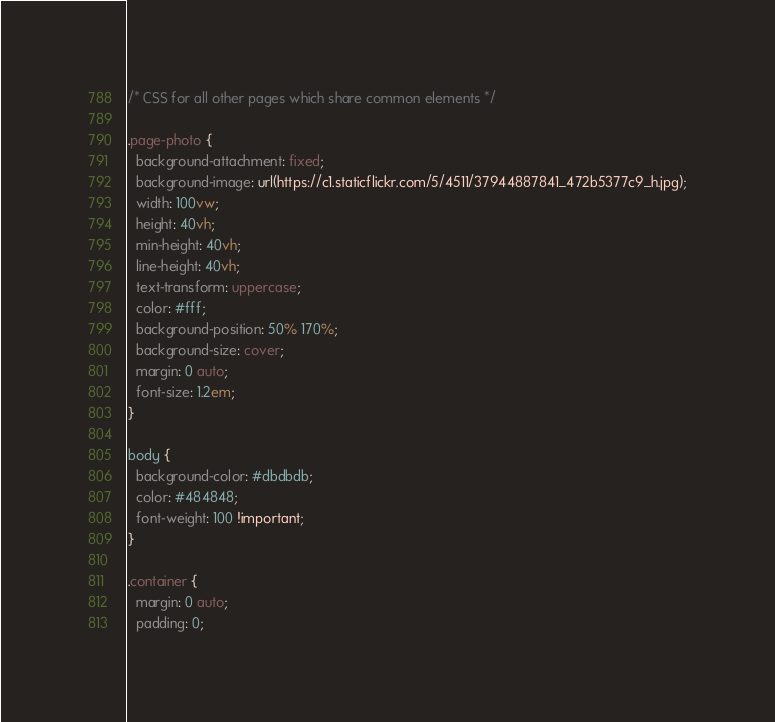Convert code to text. <code><loc_0><loc_0><loc_500><loc_500><_CSS_>/* CSS for all other pages which share common elements */

.page-photo {
  background-attachment: fixed;
  background-image: url(https://c1.staticflickr.com/5/4511/37944887841_472b5377c9_h.jpg);
  width: 100vw;
  height: 40vh;
  min-height: 40vh;
  line-height: 40vh;
  text-transform: uppercase;
  color: #fff;
  background-position: 50% 170%;
  background-size: cover;
  margin: 0 auto;    
  font-size: 1.2em;
}
  
body {
  background-color: #dbdbdb;
  color: #484848;
  font-weight: 100 !important;
}

.container {
  margin: 0 auto;  
  padding: 0;</code> 